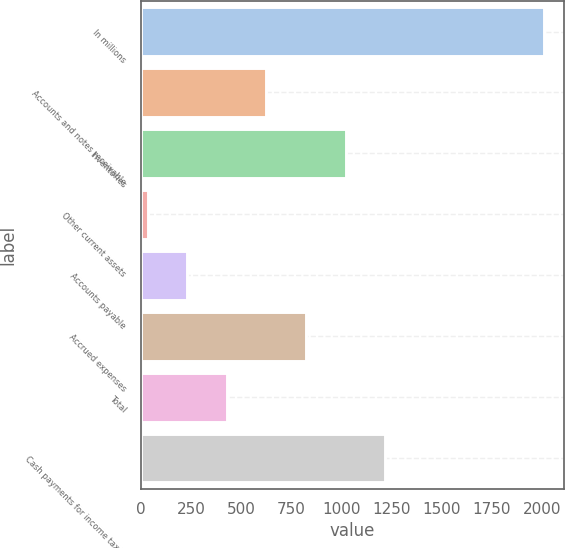Convert chart. <chart><loc_0><loc_0><loc_500><loc_500><bar_chart><fcel>In millions<fcel>Accounts and notes receivable<fcel>Inventories<fcel>Other current assets<fcel>Accounts payable<fcel>Accrued expenses<fcel>Total<fcel>Cash payments for income taxes<nl><fcel>2007<fcel>625.9<fcel>1020.5<fcel>34<fcel>231.3<fcel>823.2<fcel>428.6<fcel>1217.8<nl></chart> 